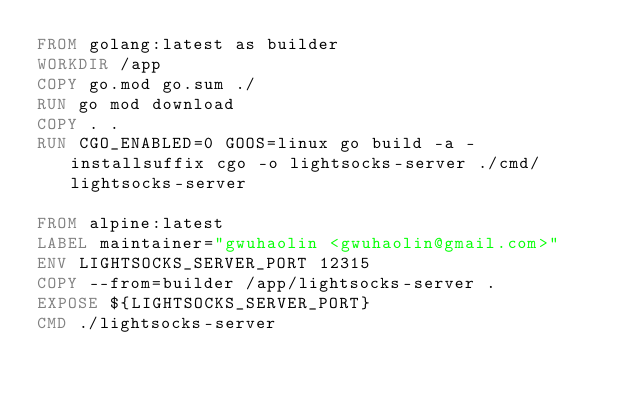Convert code to text. <code><loc_0><loc_0><loc_500><loc_500><_Dockerfile_>FROM golang:latest as builder
WORKDIR /app
COPY go.mod go.sum ./
RUN go mod download
COPY . .
RUN CGO_ENABLED=0 GOOS=linux go build -a -installsuffix cgo -o lightsocks-server ./cmd/lightsocks-server

FROM alpine:latest
LABEL maintainer="gwuhaolin <gwuhaolin@gmail.com>"
ENV LIGHTSOCKS_SERVER_PORT 12315
COPY --from=builder /app/lightsocks-server .
EXPOSE ${LIGHTSOCKS_SERVER_PORT}
CMD ./lightsocks-server</code> 